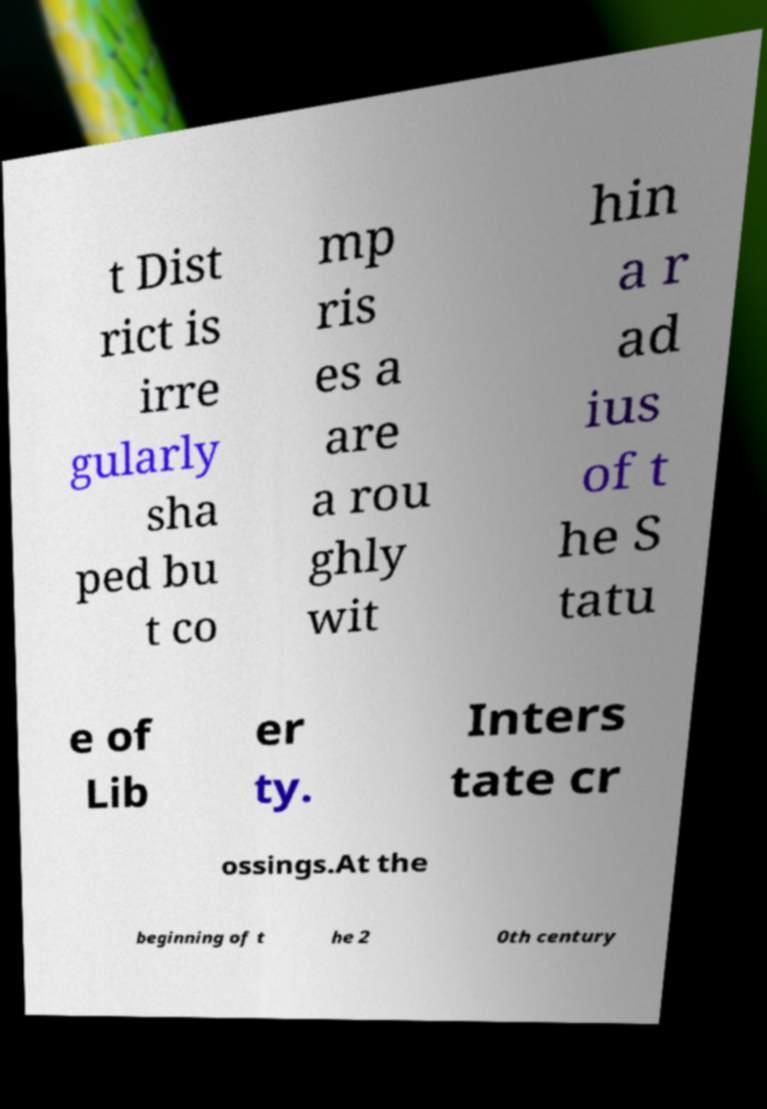Can you read and provide the text displayed in the image?This photo seems to have some interesting text. Can you extract and type it out for me? t Dist rict is irre gularly sha ped bu t co mp ris es a are a rou ghly wit hin a r ad ius of t he S tatu e of Lib er ty. Inters tate cr ossings.At the beginning of t he 2 0th century 